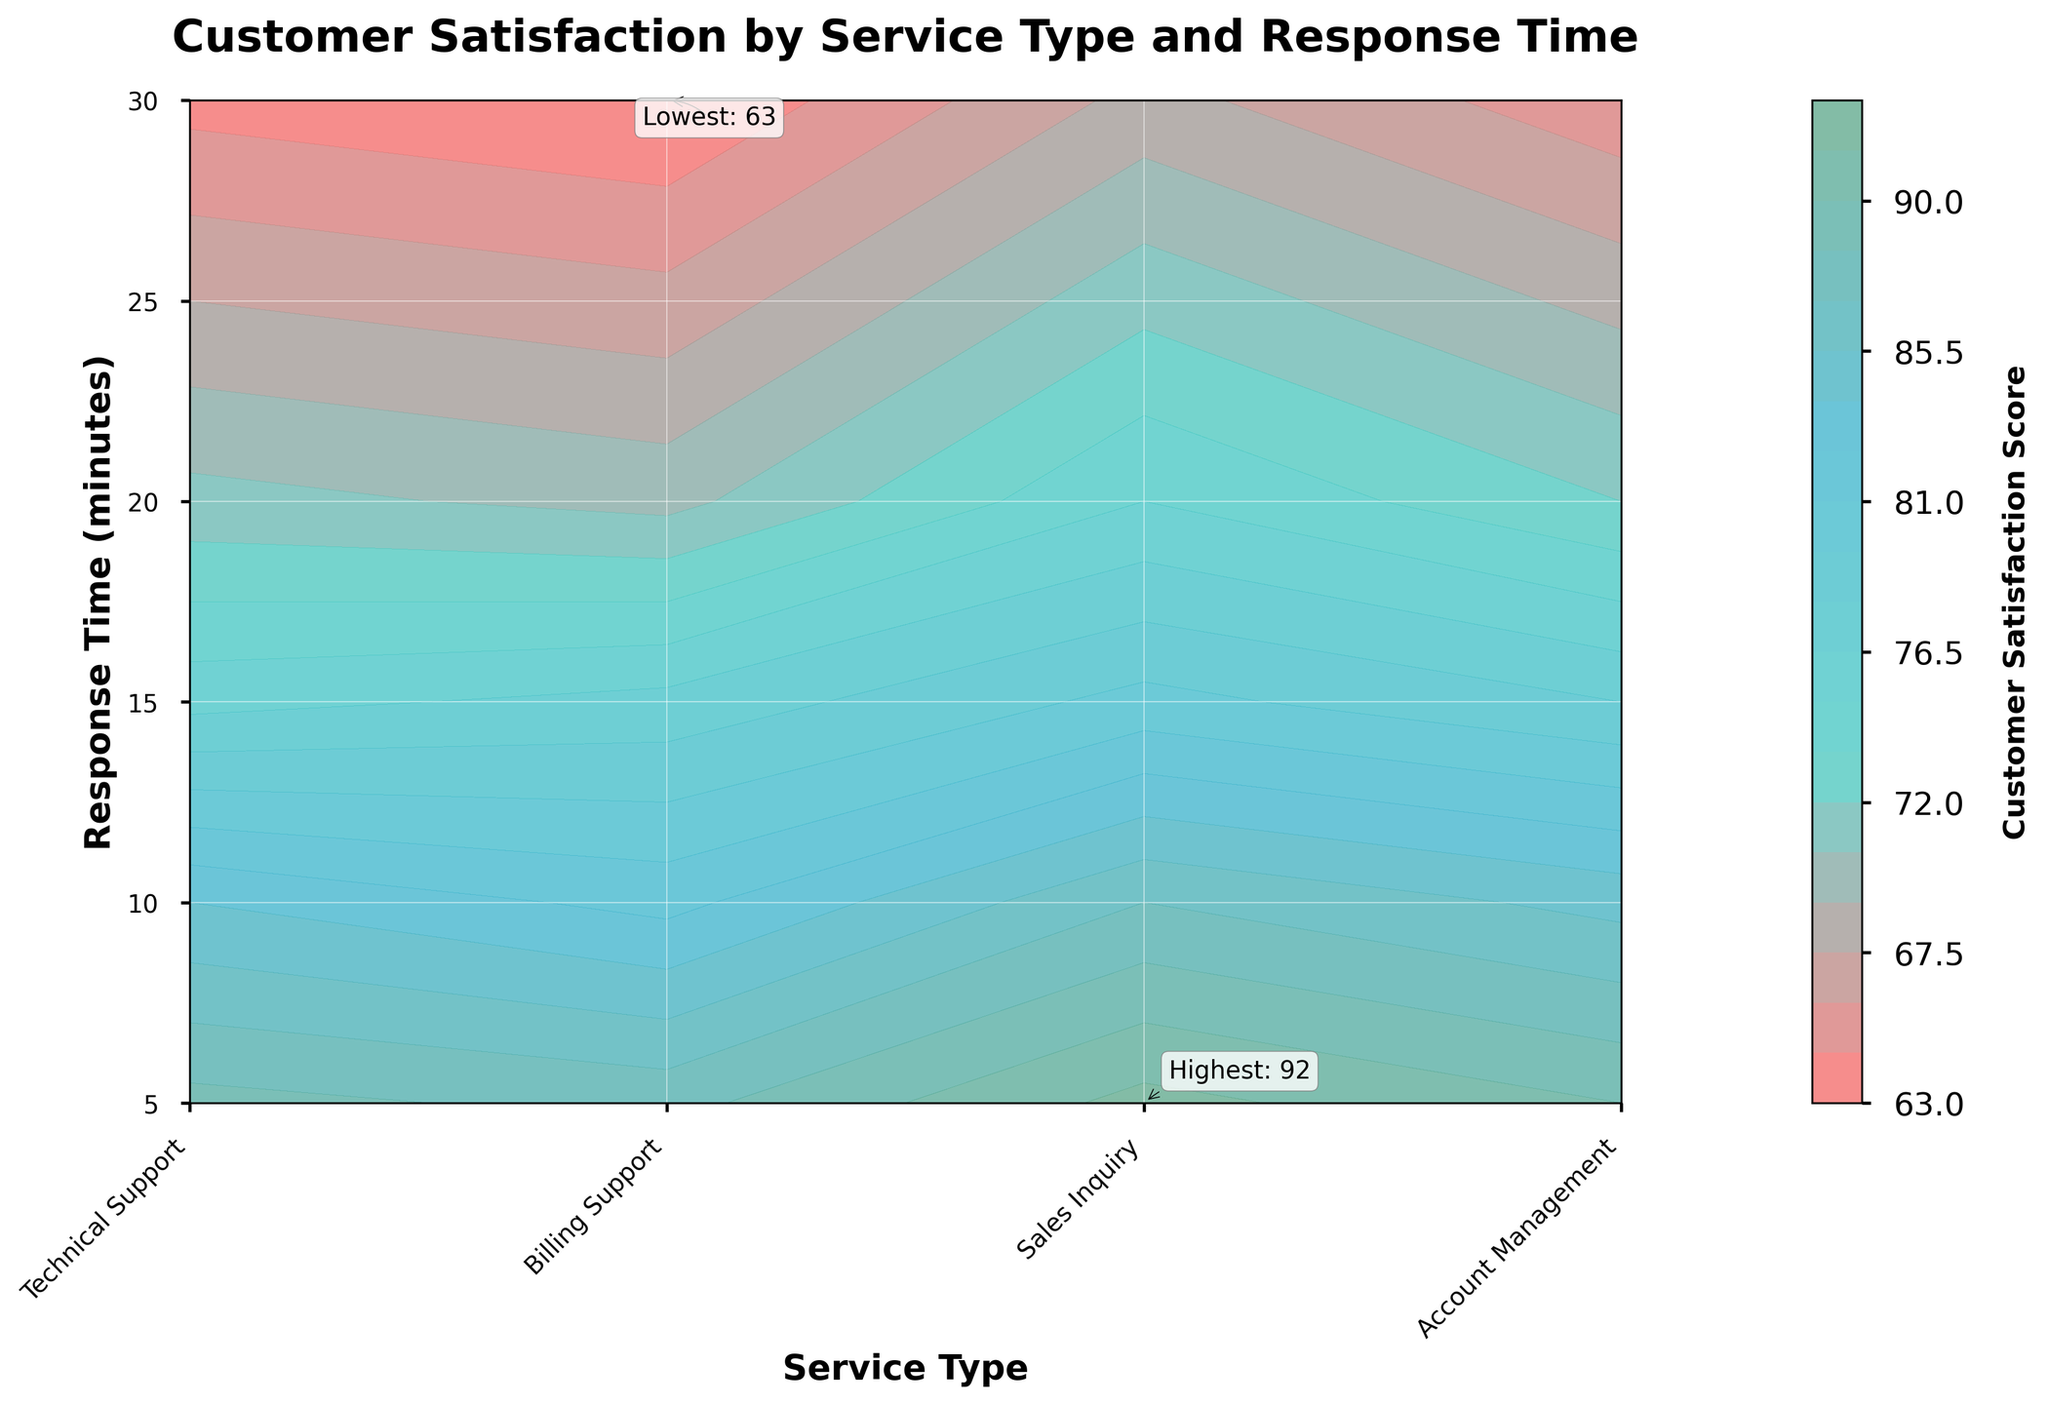What's the title of the contour plot? The title of the contour plot is located at the top center. Reading it provides an overview of what the plot represents.
Answer: Customer Satisfaction by Service Type and Response Time What is the range of response times displayed on the contour plot? The range of response times can be determined by looking at the y-axis of the plot. The minimum response time is 5 minutes, and the maximum is 30 minutes.
Answer: 5 to 30 minutes Which service type has the highest customer satisfaction score and what is the value? The highest customer satisfaction is annotated on the plot and can be identified from the contour. The highest score is for the Sales Inquiry service at a 5-minute response time. Reading the annotation gives us the value.
Answer: Sales Inquiry, 92 Which service type has the lowest customer satisfaction score and what is the value? The lowest customer satisfaction is also annotated on the plot and can be identified from the contour. The lowest score is for Billing Support at a 30-minute response time. Reading the annotation gives us the value.
Answer: Billing Support, 63 How does customer satisfaction vary with response time for Technical Support? Analyzing the Technical Support contour reveals that as the response time increases from 5 to 30 minutes, customer satisfaction scores decrease continuously.
Answer: Decreases Compare the satisfaction scores between Billing Support and Account Management for a 10-minute response time. By examining the values on the contour lines or the color intensities at the intersection of Billing Support and Account Management with a 10-minute response time, we can compare the satisfaction scores. Billing Support has a score of 82, and Account Management has a score of 84.
Answer: Account Management is higher What is the average customer satisfaction score for a response time of 15 minutes across all service types? To find the average score, locate the values for Technical Support, Billing Support, Sales Inquiry, and Account Management at 15 minutes: 78, 77, 80, and 76 respectively. Sum these scores and divide by the number of service types. (78 + 77 + 80 + 76) / 4 = 311 / 4
Answer: 77.75 Which service type shows the steepest decline in customer satisfaction as response time increases from 5 minutes to 30 minutes? Observing the contour lines for each service type, the steepest decline is indicated by the sharpest change in color. Technical Support, declining from 90 to 65, represents the steepest decline.
Answer: Technical Support What is the color representing the highest customer satisfaction score on the contour plot? The highest customer satisfaction score of 92 is annotated on the plot. Looking at its corresponding color on the plot reveals it to be a shade of greenish-blue.
Answer: Greenish-blue What trends can be observed from the contour plot regarding customer satisfaction with increasing response times? Examining the contour plot, a general trend can be observed where customer satisfaction scores decrease for all service types as response times increase. The contours show a gradient of decreasing satisfaction scores from left to right along the y-axis.
Answer: Decreases with increasing response times 